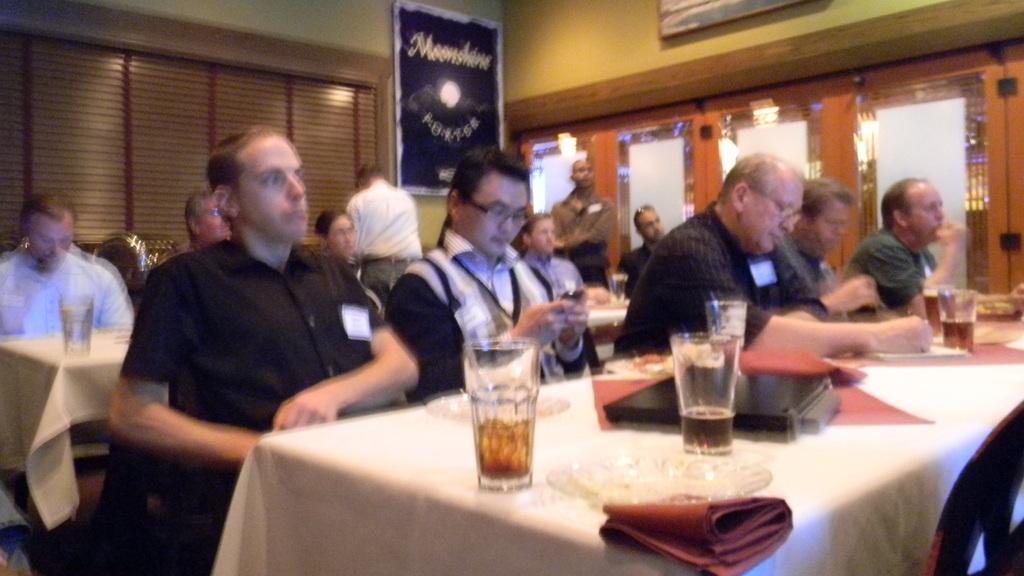Could you give a brief overview of what you see in this image? In this image I can see few people are sitting beside the table. The tables are covered with a white cloth on the table, there are glasses and clothes. In the background there is a wall and a frame is attached to this wall. 